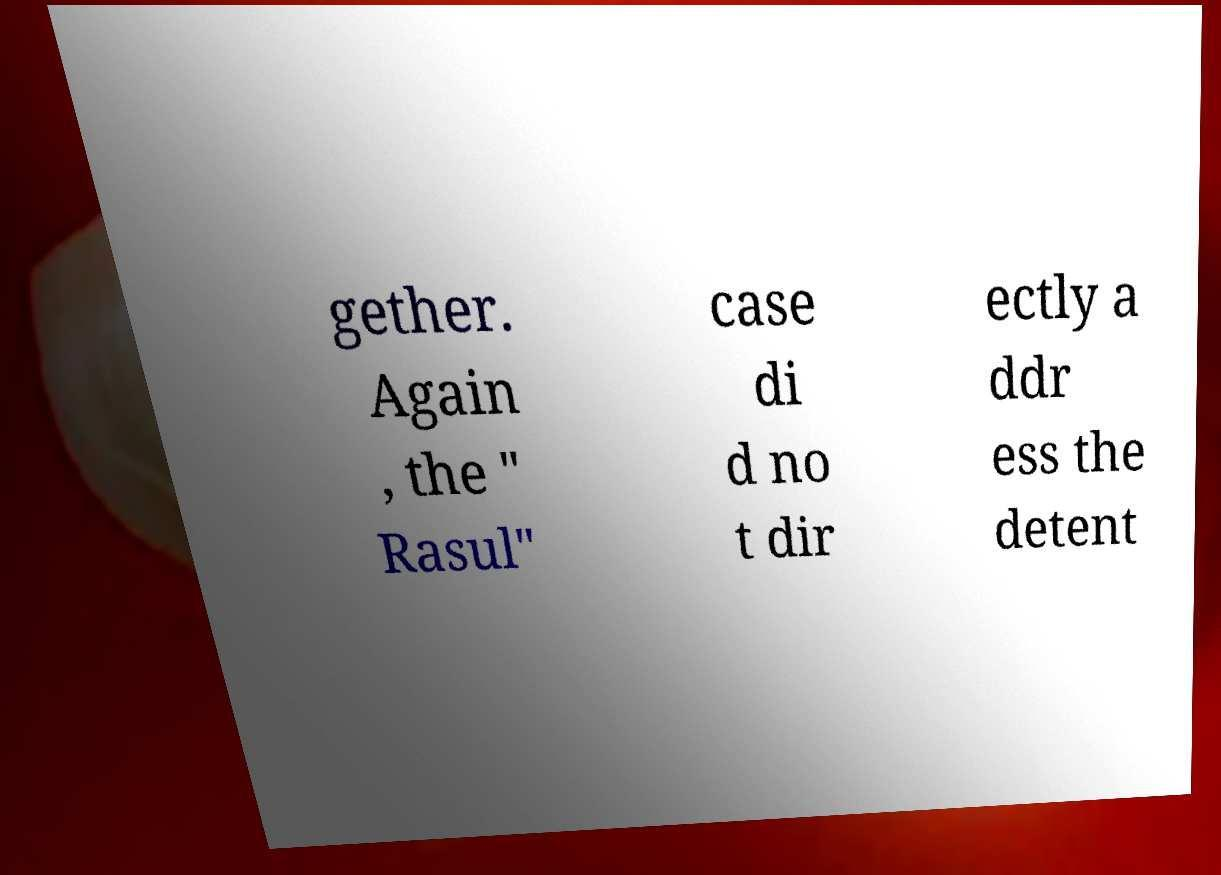Could you extract and type out the text from this image? gether. Again , the " Rasul" case di d no t dir ectly a ddr ess the detent 